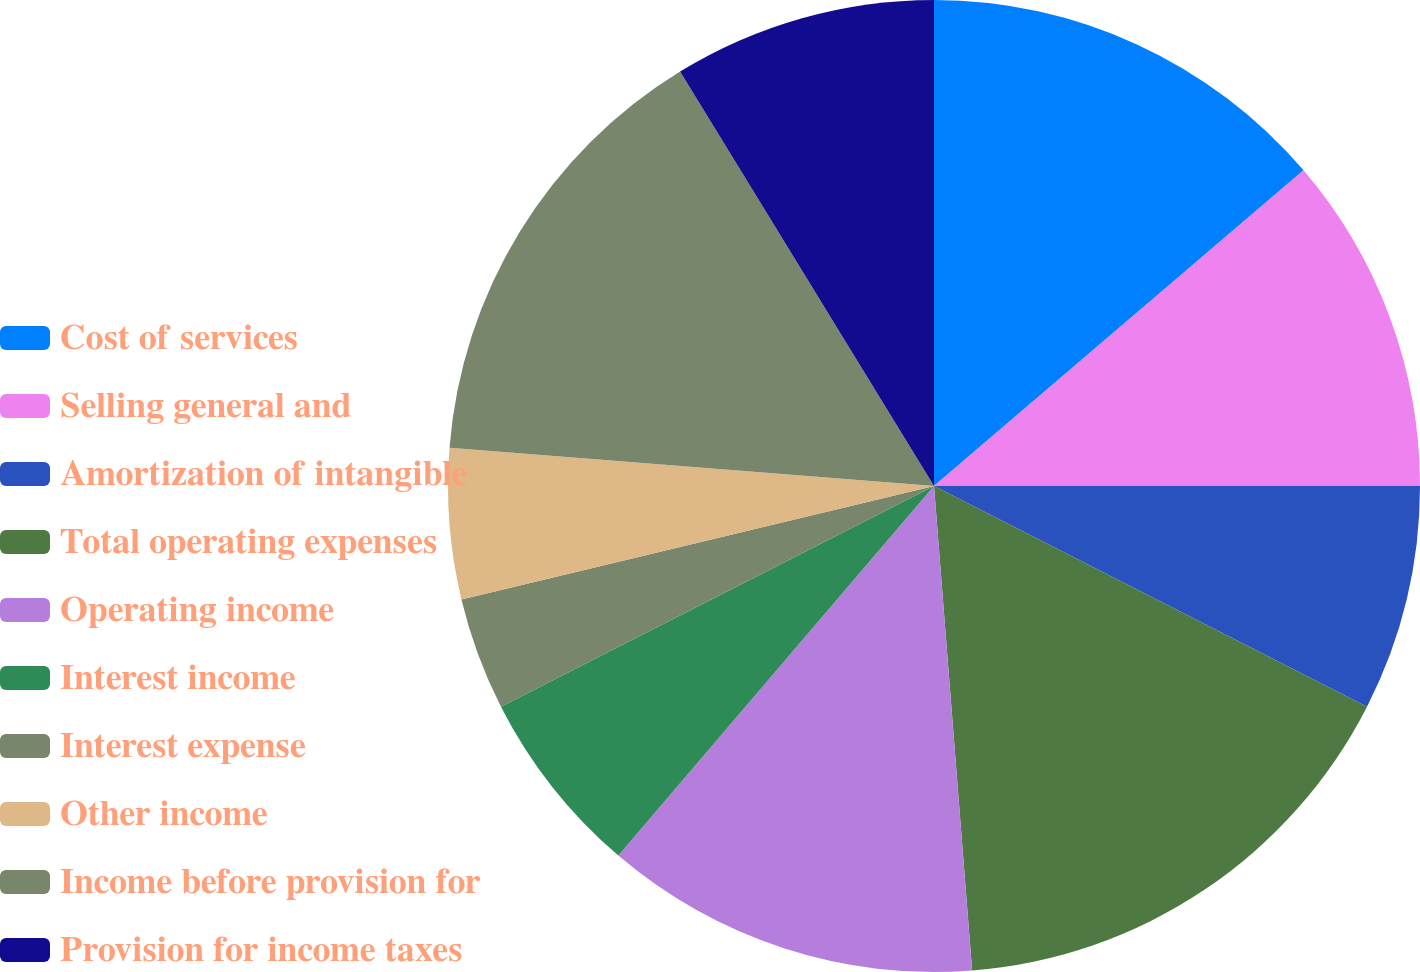Convert chart to OTSL. <chart><loc_0><loc_0><loc_500><loc_500><pie_chart><fcel>Cost of services<fcel>Selling general and<fcel>Amortization of intangible<fcel>Total operating expenses<fcel>Operating income<fcel>Interest income<fcel>Interest expense<fcel>Other income<fcel>Income before provision for<fcel>Provision for income taxes<nl><fcel>13.75%<fcel>11.25%<fcel>7.5%<fcel>16.25%<fcel>12.5%<fcel>6.25%<fcel>3.75%<fcel>5.0%<fcel>15.0%<fcel>8.75%<nl></chart> 